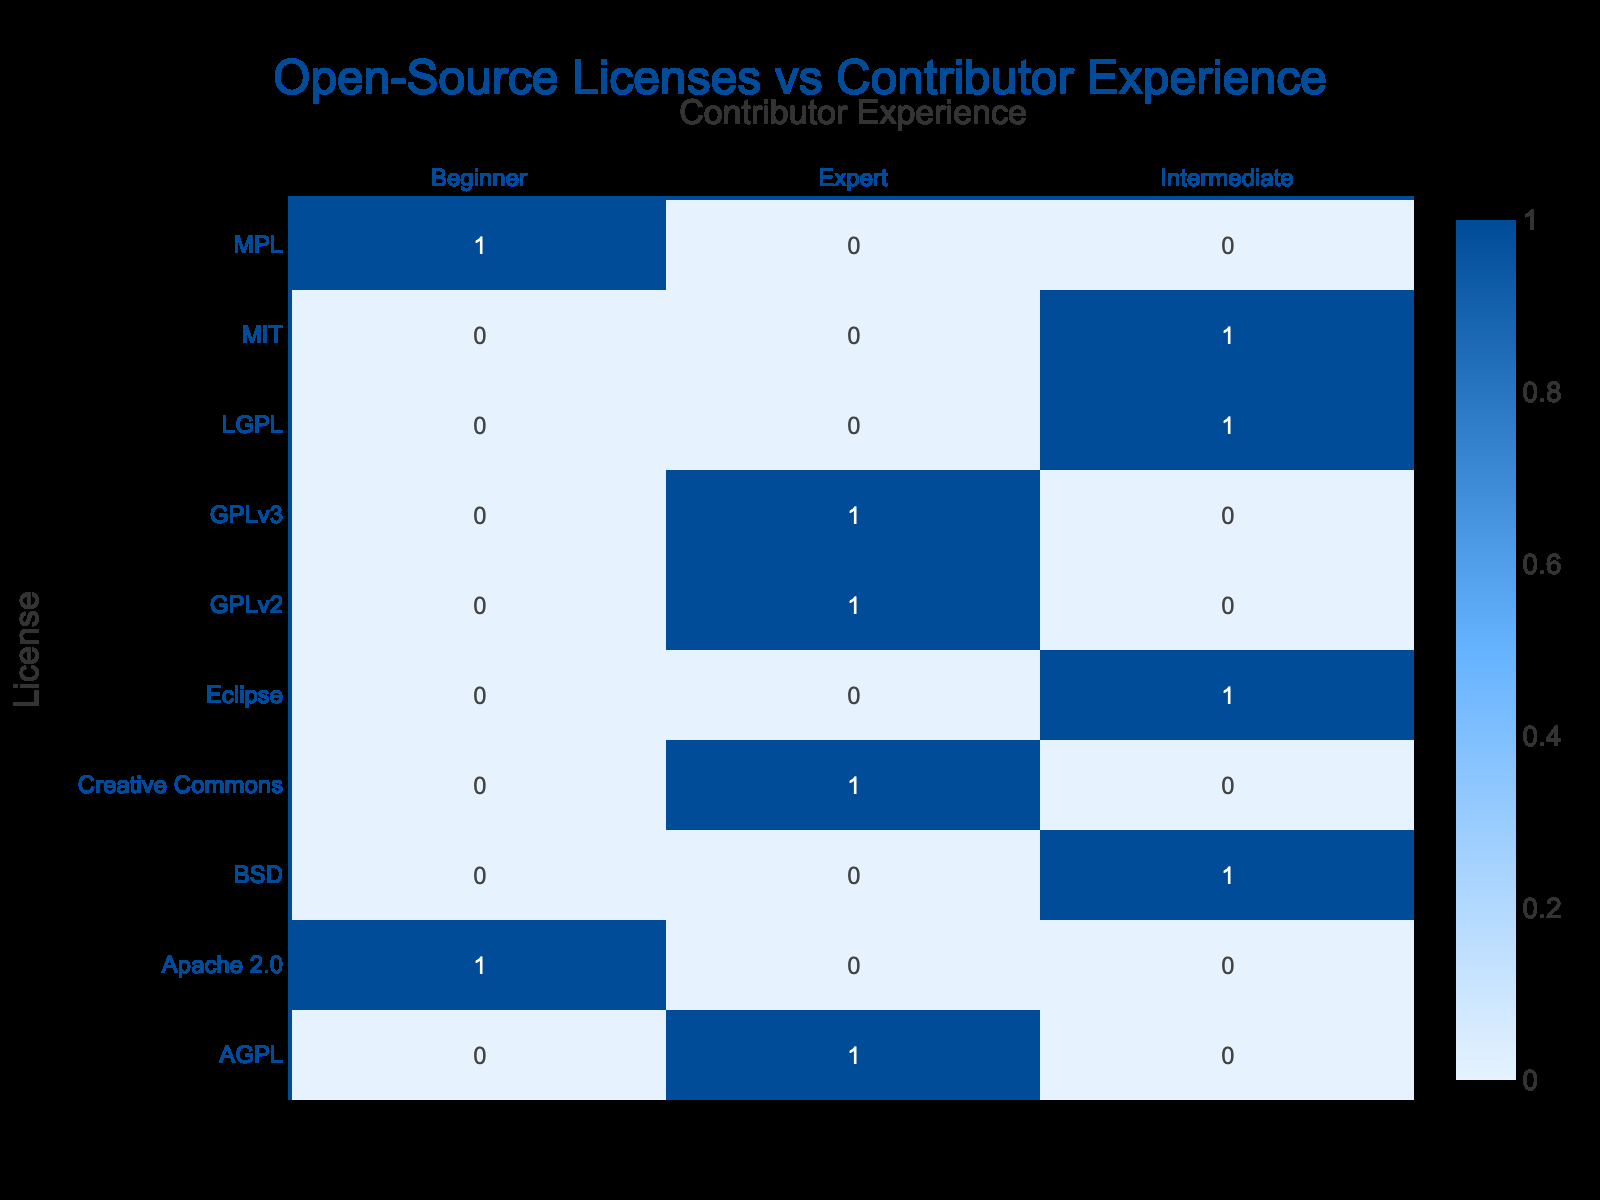What license has the highest number of contributors with intermediate experience? By reviewing the table, I count the number of contributors with intermediate experience for each license. The MIT license has 1 contributor, the BSD license has 1, the LGPL has 1, and the Eclipse license has 1. Therefore, there is no license with a higher number, as they all have the same count.
Answer: No license Is there a contributor with expert experience working on projects with the Apache 2.0 license? To answer this, I cross-reference the contributor experience with the license types. Upon checking, there are no entries under the Apache 2.0 license for expert experience.
Answer: No How many contributors with beginner experience are involved in mobile applications? The table indicates that there is one contributor with beginner experience for the Apache 2.0 license, which is specifically tied to mobile applications. Therefore, the answer is 1.
Answer: 1 Which contributor experience is most common for projects using the GPLv2 license? Observing the table, I can see that the GPLv2 license is associated with expert contributors. There is only one entry for GPLv2, and that contributor has expert experience.
Answer: Expert If we add up all contributors with expert experience, what would that total be? I count the number of contributors categorized as expert across all licenses: there are 5 expert contributors (GPLv3, GPLv2, Creative Commons, AGPL). Adding them together gives us a total of 5 contributors.
Answer: 5 Is the number of contributors with intermediate experience greater than those with beginner experience? Checking the data, there are 4 intermediate contributors (MIT, BSD, LGPL, Eclipse) and only 2 beginners (Apache 2.0, MPL). Thus, the intermediate contributors outnumber the beginner contributors.
Answer: Yes How many different licenses have contributors with beginner experience? From the table, I count the licenses that have entries for beginner experience: Apache 2.0 and MPL. Thus, there are 2 different licenses associated with beginners.
Answer: 2 Is there any license associated with both expert and beginner experiences? Looking at the table, there are no licenses that have entries for both expert and beginner experiences. The only licenses that have expert experience have none for beginner and vice versa.
Answer: No 